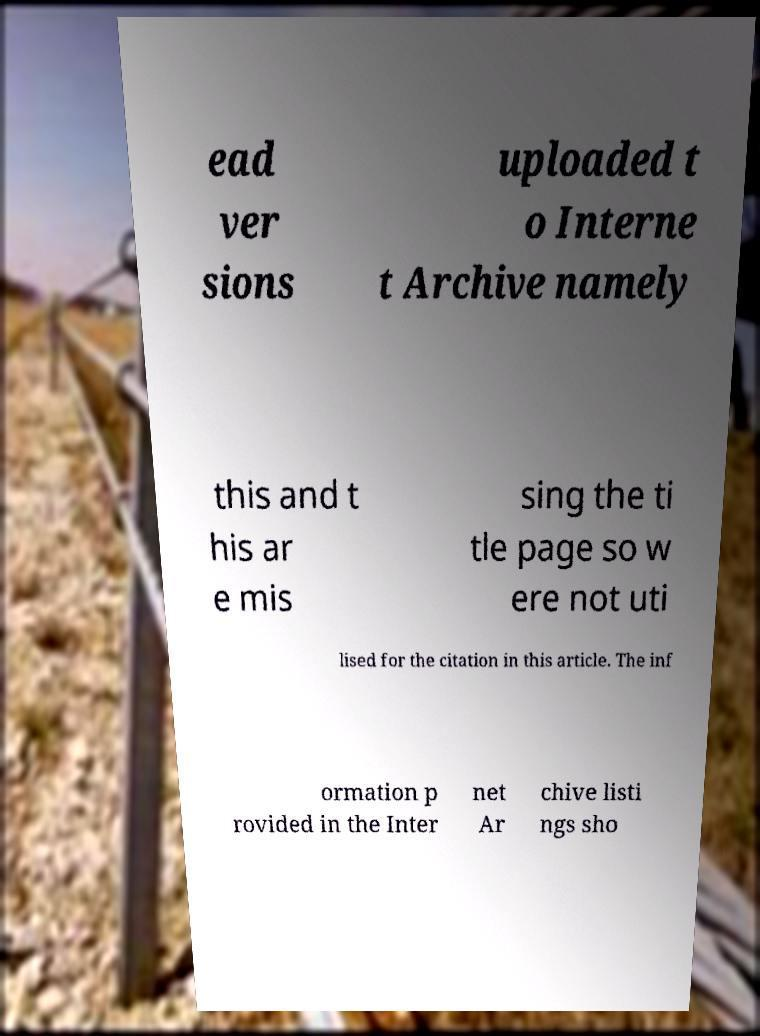Can you accurately transcribe the text from the provided image for me? ead ver sions uploaded t o Interne t Archive namely this and t his ar e mis sing the ti tle page so w ere not uti lised for the citation in this article. The inf ormation p rovided in the Inter net Ar chive listi ngs sho 